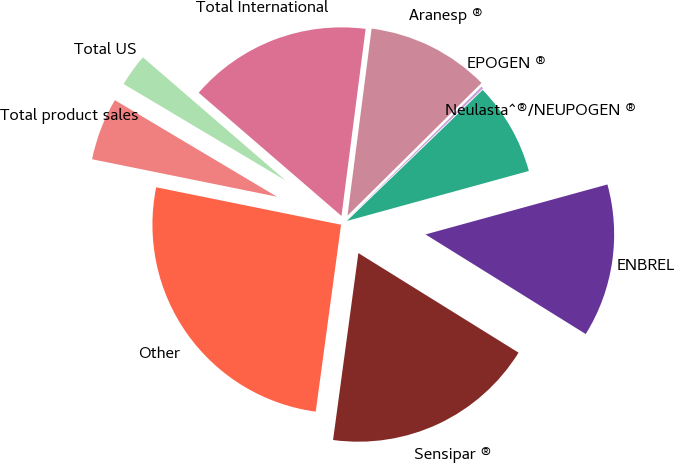<chart> <loc_0><loc_0><loc_500><loc_500><pie_chart><fcel>Aranesp ®<fcel>EPOGEN ®<fcel>Neulasta^®/NEUPOGEN ®<fcel>ENBREL<fcel>Sensipar ®<fcel>Other<fcel>Total product sales<fcel>Total US<fcel>Total International<nl><fcel>10.54%<fcel>0.2%<fcel>7.95%<fcel>13.12%<fcel>18.29%<fcel>26.04%<fcel>5.37%<fcel>2.78%<fcel>15.71%<nl></chart> 